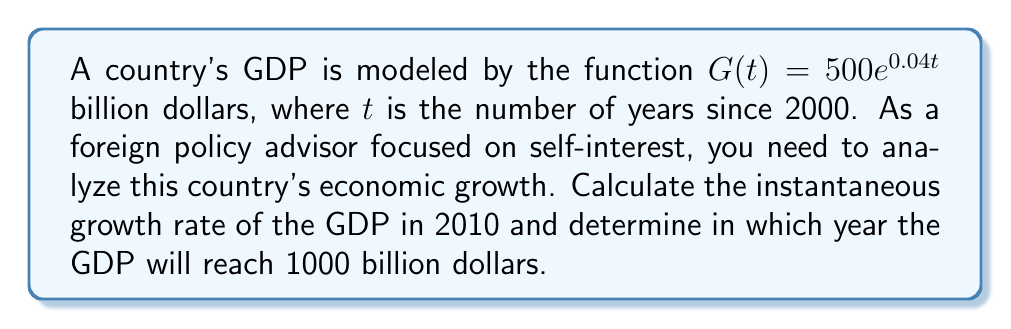Can you answer this question? 1. To find the instantaneous growth rate in 2010, we need to calculate the derivative of $G(t)$ and evaluate it at $t=10$ (since 2010 is 10 years after 2000).

   $G'(t) = 500 \cdot 0.04e^{0.04t}$ = $20e^{0.04t}$

   At $t=10$: $G'(10) = 20e^{0.04 \cdot 10} = 20e^{0.4} \approx 29.72$ billion dollars per year

2. To find when the GDP will reach 1000 billion dollars, we need to solve the equation:

   $500e^{0.04t} = 1000$

   Dividing both sides by 500:
   $e^{0.04t} = 2$

   Taking the natural logarithm of both sides:
   $\ln(e^{0.04t}) = \ln(2)$
   $0.04t = \ln(2)$

   Solving for $t$:
   $t = \frac{\ln(2)}{0.04} \approx 17.33$ years

   Since $t$ is measured from 2000, this corresponds to approximately the year 2017.
Answer: The instantaneous growth rate in 2010 is approximately $29.72$ billion dollars per year. The GDP will reach 1000 billion dollars in approximately 17.33 years after 2000, which is around the year 2017. 